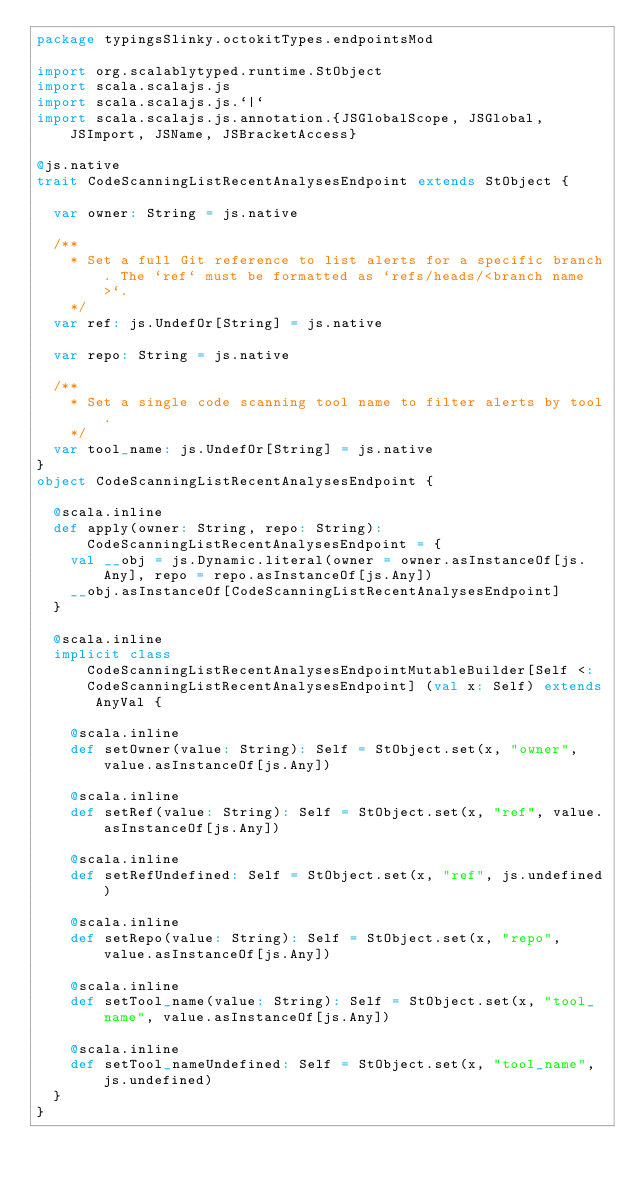<code> <loc_0><loc_0><loc_500><loc_500><_Scala_>package typingsSlinky.octokitTypes.endpointsMod

import org.scalablytyped.runtime.StObject
import scala.scalajs.js
import scala.scalajs.js.`|`
import scala.scalajs.js.annotation.{JSGlobalScope, JSGlobal, JSImport, JSName, JSBracketAccess}

@js.native
trait CodeScanningListRecentAnalysesEndpoint extends StObject {
  
  var owner: String = js.native
  
  /**
    * Set a full Git reference to list alerts for a specific branch. The `ref` must be formatted as `refs/heads/<branch name>`.
    */
  var ref: js.UndefOr[String] = js.native
  
  var repo: String = js.native
  
  /**
    * Set a single code scanning tool name to filter alerts by tool.
    */
  var tool_name: js.UndefOr[String] = js.native
}
object CodeScanningListRecentAnalysesEndpoint {
  
  @scala.inline
  def apply(owner: String, repo: String): CodeScanningListRecentAnalysesEndpoint = {
    val __obj = js.Dynamic.literal(owner = owner.asInstanceOf[js.Any], repo = repo.asInstanceOf[js.Any])
    __obj.asInstanceOf[CodeScanningListRecentAnalysesEndpoint]
  }
  
  @scala.inline
  implicit class CodeScanningListRecentAnalysesEndpointMutableBuilder[Self <: CodeScanningListRecentAnalysesEndpoint] (val x: Self) extends AnyVal {
    
    @scala.inline
    def setOwner(value: String): Self = StObject.set(x, "owner", value.asInstanceOf[js.Any])
    
    @scala.inline
    def setRef(value: String): Self = StObject.set(x, "ref", value.asInstanceOf[js.Any])
    
    @scala.inline
    def setRefUndefined: Self = StObject.set(x, "ref", js.undefined)
    
    @scala.inline
    def setRepo(value: String): Self = StObject.set(x, "repo", value.asInstanceOf[js.Any])
    
    @scala.inline
    def setTool_name(value: String): Self = StObject.set(x, "tool_name", value.asInstanceOf[js.Any])
    
    @scala.inline
    def setTool_nameUndefined: Self = StObject.set(x, "tool_name", js.undefined)
  }
}
</code> 